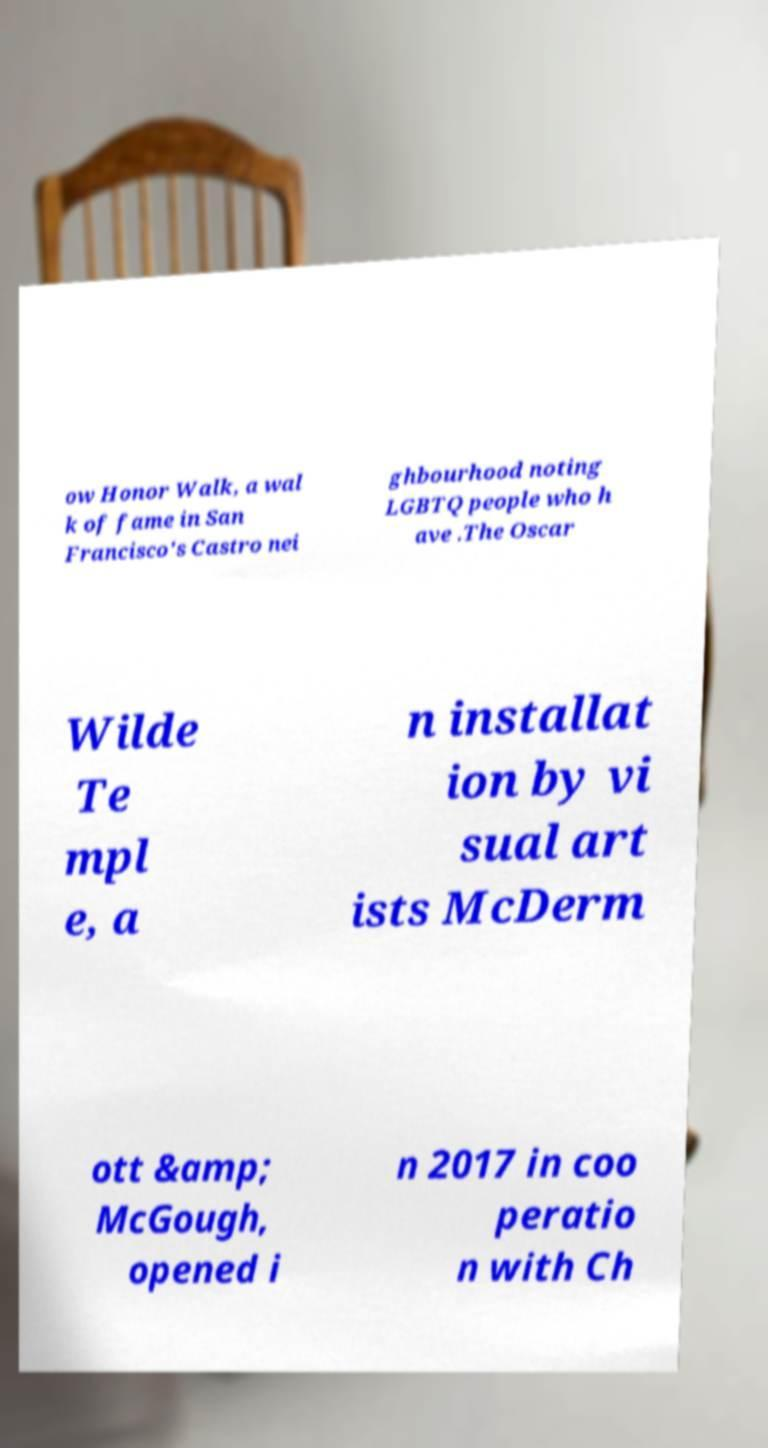I need the written content from this picture converted into text. Can you do that? ow Honor Walk, a wal k of fame in San Francisco's Castro nei ghbourhood noting LGBTQ people who h ave .The Oscar Wilde Te mpl e, a n installat ion by vi sual art ists McDerm ott &amp; McGough, opened i n 2017 in coo peratio n with Ch 